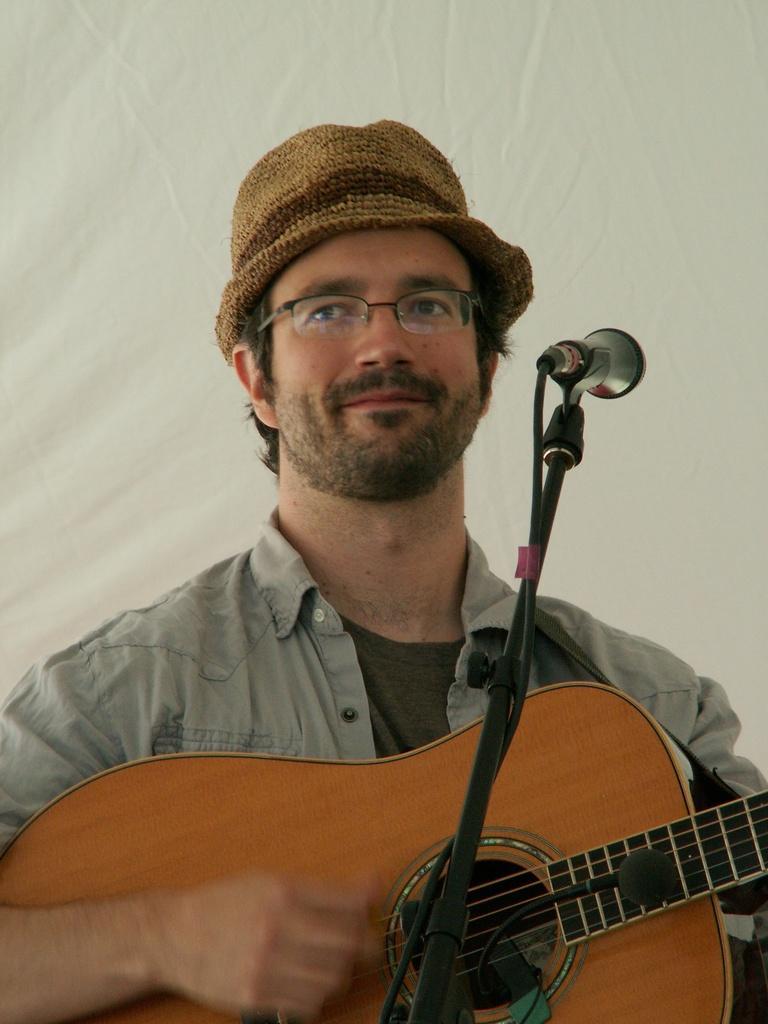Could you give a brief overview of what you see in this image? In this picture there is a man at the center of the image, by holding the guitar and there is a mic in front of the man and his wearing a hat around his head. 